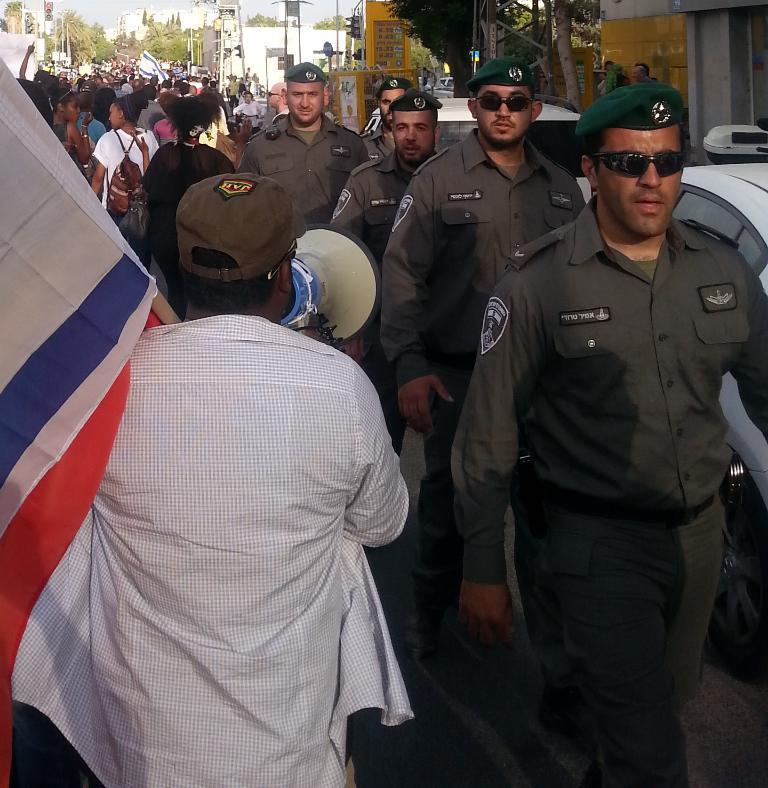Please provide a concise description of this image. In this image I can see number of people are standing. I can see few of them are wearing uniforms, shades, caps and here I can see one of them is holding a megaphone. I can also see few vehicles, number of buildings, number of moles and number of trees. 